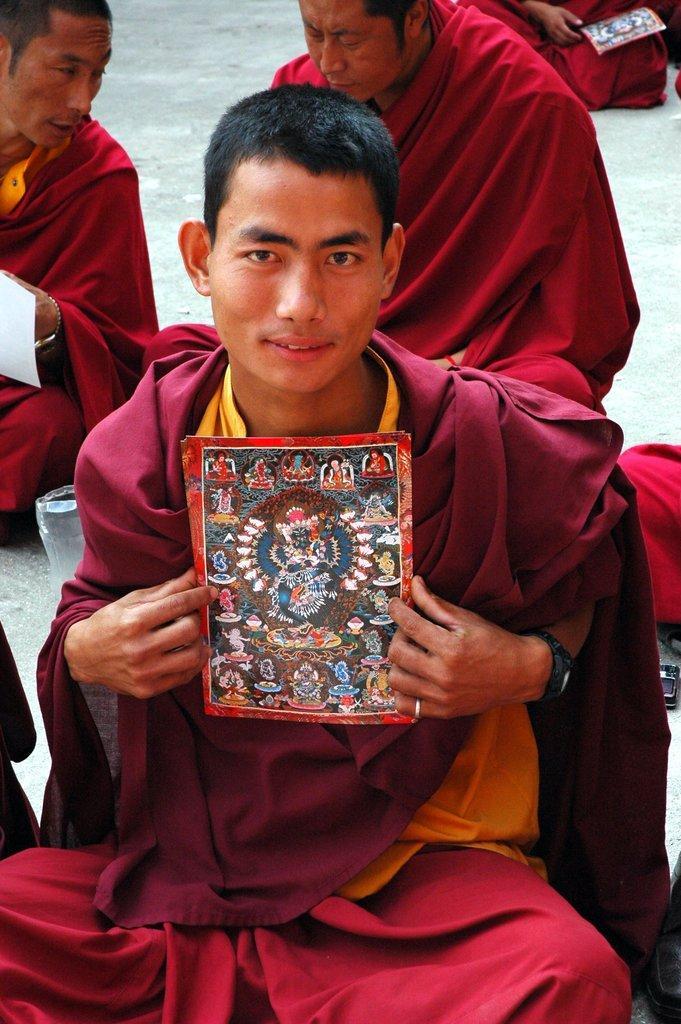Describe this image in one or two sentences. In this image there is a saint in red costume is sitting and holding paper in his hands, behind him there are so many other saints sitting and talking among them. 